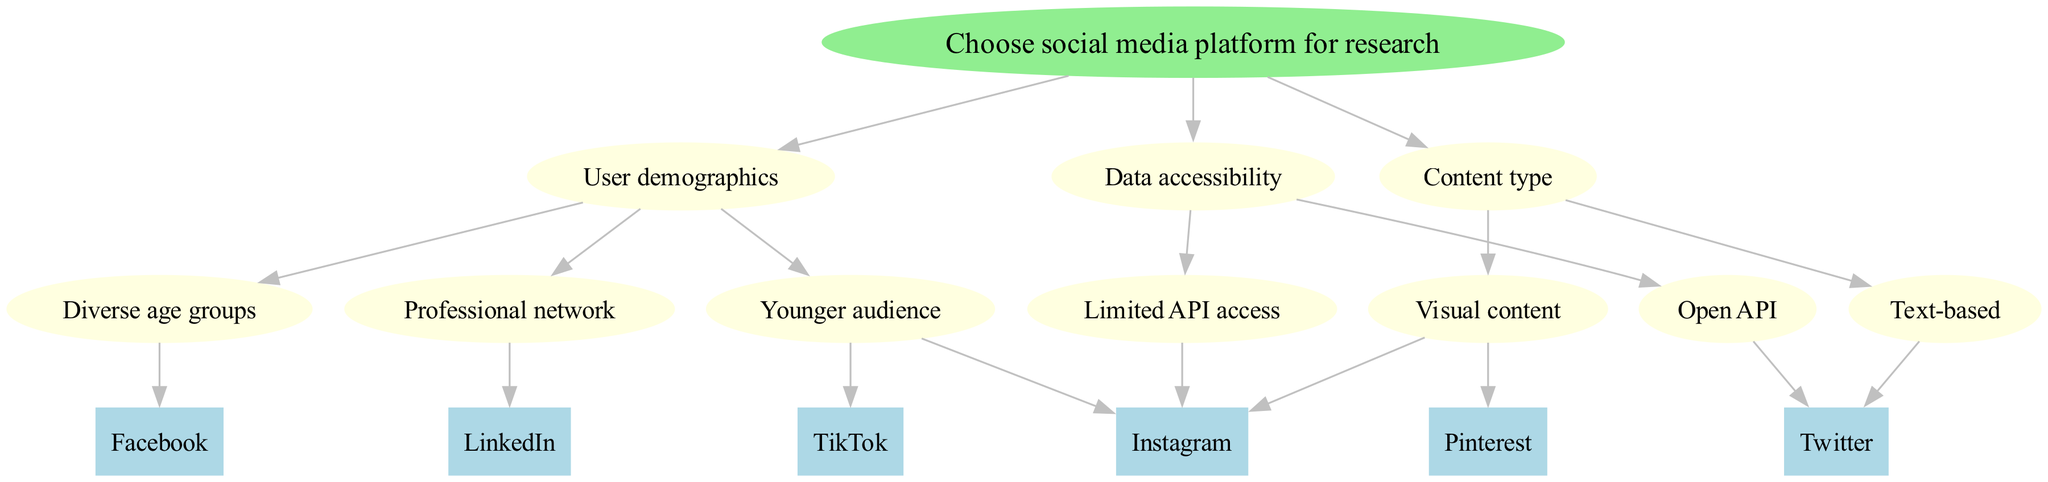What is the root of the decision tree? The root of the decision tree is the starting point which is labeled as "Choose social media platform for research".
Answer: Choose social media platform for research How many main factors are considered in the decision tree? There are three main factors in the decision tree: "User demographics", "Data accessibility", and "Content type".
Answer: 3 Which social media platform is associated with a diverse age group? According to the decision tree, "Facebook" is linked to users in diverse age groups, indicating it caters to a broad demographic.
Answer: Facebook What type of content is Twitter associated with? The decision tree categorizes Twitter under "Text-based" content, suggesting it primarily hosts textual information.
Answer: Text-based Which platform has an open API according to the diagram? "Twitter" is the platform mentioned in the decision tree that offers an open API, enabling greater data access for researchers.
Answer: Twitter If the user is looking for visual content, which platforms can be selected? The decision tree indicates two platforms for visual content: "Instagram" and "Pinterest", either of which could be chosen based on the user's needs.
Answer: Instagram and Pinterest Which platform is suitable for a professional network? The decision tree specifies "LinkedIn" as the social media platform tailored for professional networking purposes.
Answer: LinkedIn What is the relationship between user demographics and content type in the diagram? User demographics and content type are separate evaluation criteria in the decision tree, indicating that either can independently influence platform choice, rather than being interdependent variables.
Answer: Separate Which social media platform has limited API access? Based on the decision tree, "Instagram" is identified as having limited API access for researchers.
Answer: Instagram How many leaves are there in the tree for data accessibility? The tree lists two leaves under data accessibility: "Twitter" for open API and "Instagram" for limited API access, resulting in a total of two leaves.
Answer: 2 